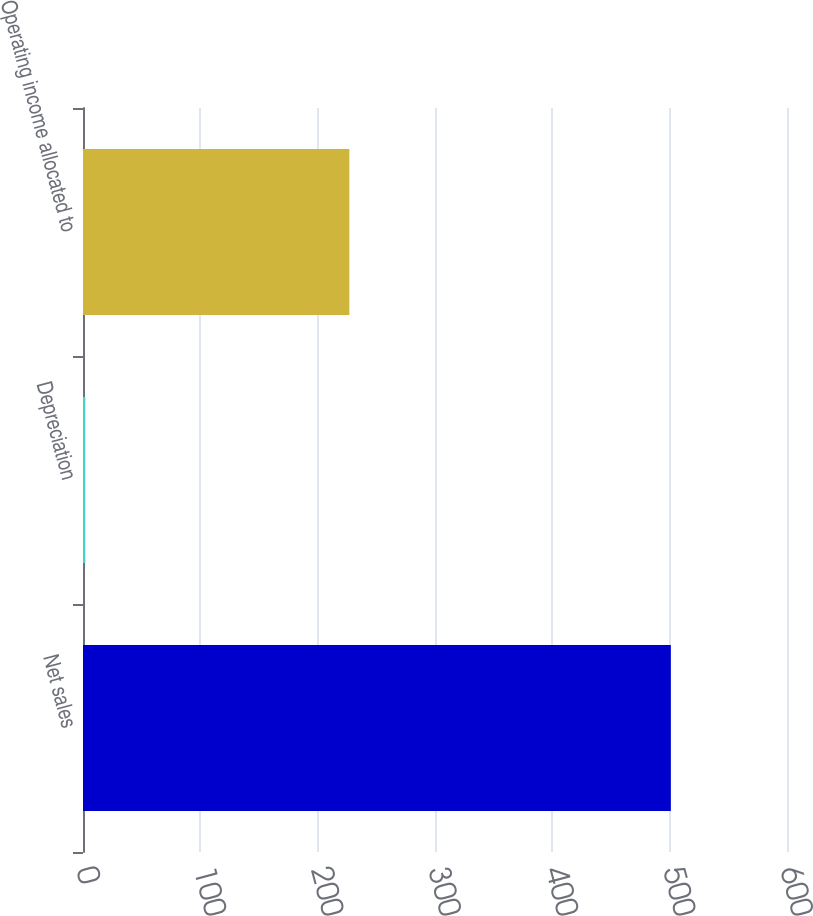Convert chart. <chart><loc_0><loc_0><loc_500><loc_500><bar_chart><fcel>Net sales<fcel>Depreciation<fcel>Operating income allocated to<nl><fcel>501<fcel>2<fcel>227<nl></chart> 